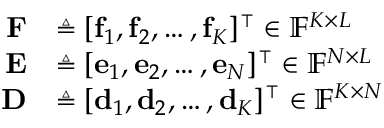<formula> <loc_0><loc_0><loc_500><loc_500>\begin{array} { r l } { F } & { \triangle q [ f _ { 1 } , f _ { 2 } , \hdots , f _ { K } ] ^ { \intercal } \in \mathbb { F } ^ { K \times L } } \\ { E } & { \triangle q [ e _ { 1 } , e _ { 2 } , \hdots , e _ { N } ] ^ { \intercal } \in \mathbb { F } ^ { N \times L } } \\ { D } & { \triangle q [ d _ { 1 } , d _ { 2 } , \hdots , d _ { K } ] ^ { \intercal } \in \mathbb { F } ^ { K \times N } } \end{array}</formula> 